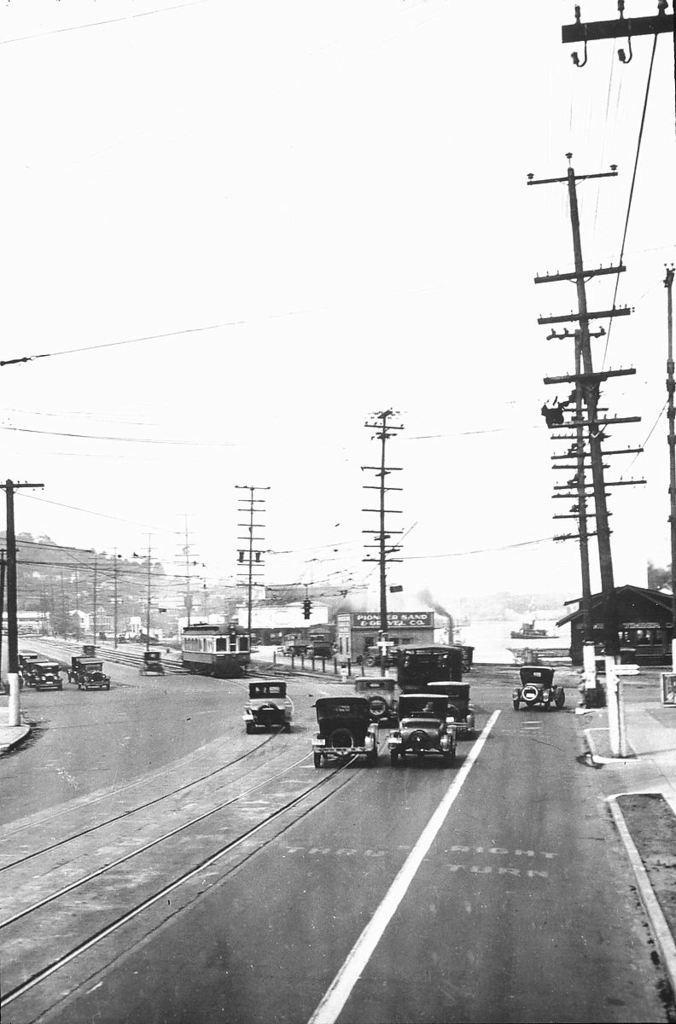How would you summarize this image in a sentence or two? In this picture I can see there are few vehicles moving on the road and there are few electric poles and the wires are connected to it. The sky is clear. 